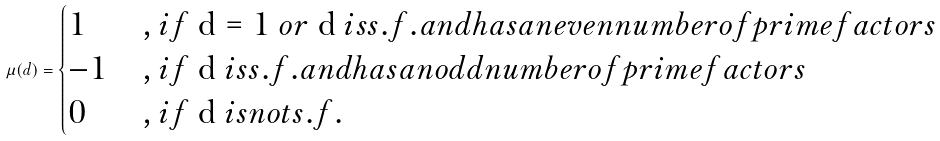<formula> <loc_0><loc_0><loc_500><loc_500>\mu ( d ) = \begin{cases} 1 & , i f $ d = 1 $ o r $ d $ i s s . f . a n d h a s a n e v e n n u m b e r o f p r i m e f a c t o r s \\ - 1 & , i f $ d $ i s s . f . a n d h a s a n o d d n u m b e r o f p r i m e f a c t o r s \\ 0 & , i f $ d $ i s n o t s . f . \end{cases}</formula> 